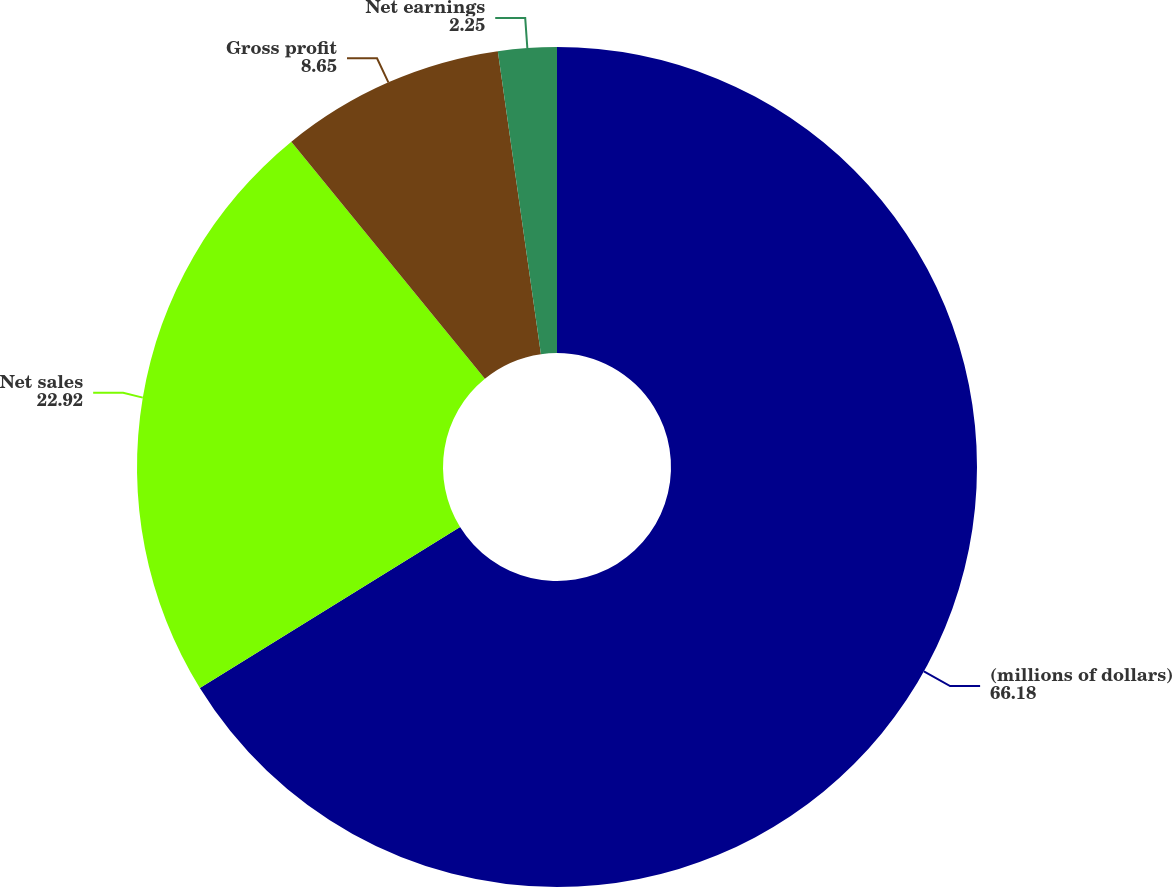<chart> <loc_0><loc_0><loc_500><loc_500><pie_chart><fcel>(millions of dollars)<fcel>Net sales<fcel>Gross profit<fcel>Net earnings<nl><fcel>66.18%<fcel>22.92%<fcel>8.65%<fcel>2.25%<nl></chart> 